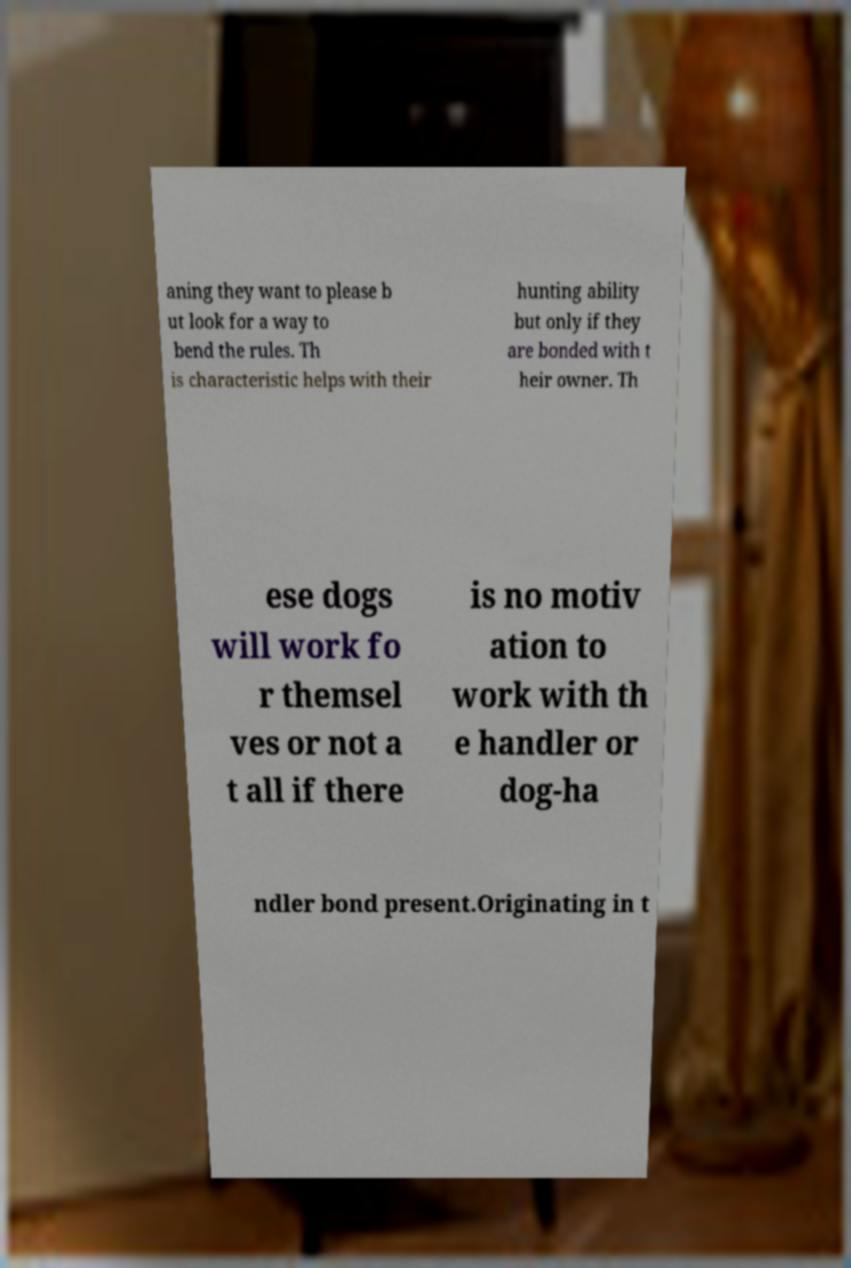Please identify and transcribe the text found in this image. aning they want to please b ut look for a way to bend the rules. Th is characteristic helps with their hunting ability but only if they are bonded with t heir owner. Th ese dogs will work fo r themsel ves or not a t all if there is no motiv ation to work with th e handler or dog-ha ndler bond present.Originating in t 